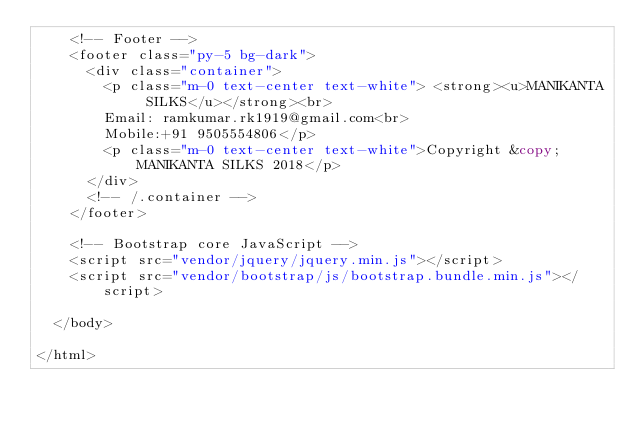Convert code to text. <code><loc_0><loc_0><loc_500><loc_500><_PHP_>    <!-- Footer -->
    <footer class="py-5 bg-dark">
      <div class="container">
        <p class="m-0 text-center text-white"> <strong><u>MANIKANTA SILKS</u></strong><br>
        Email: ramkumar.rk1919@gmail.com<br>
        Mobile:+91 9505554806</p>
        <p class="m-0 text-center text-white">Copyright &copy; MANIKANTA SILKS 2018</p>
      </div>
      <!-- /.container -->
    </footer>

    <!-- Bootstrap core JavaScript -->
    <script src="vendor/jquery/jquery.min.js"></script>
    <script src="vendor/bootstrap/js/bootstrap.bundle.min.js"></script>

  </body>

</html>
</code> 